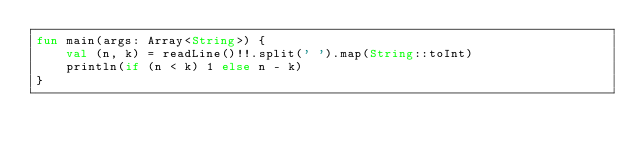Convert code to text. <code><loc_0><loc_0><loc_500><loc_500><_Kotlin_>fun main(args: Array<String>) {
    val (n, k) = readLine()!!.split(' ').map(String::toInt)
    println(if (n < k) 1 else n - k)
}
</code> 